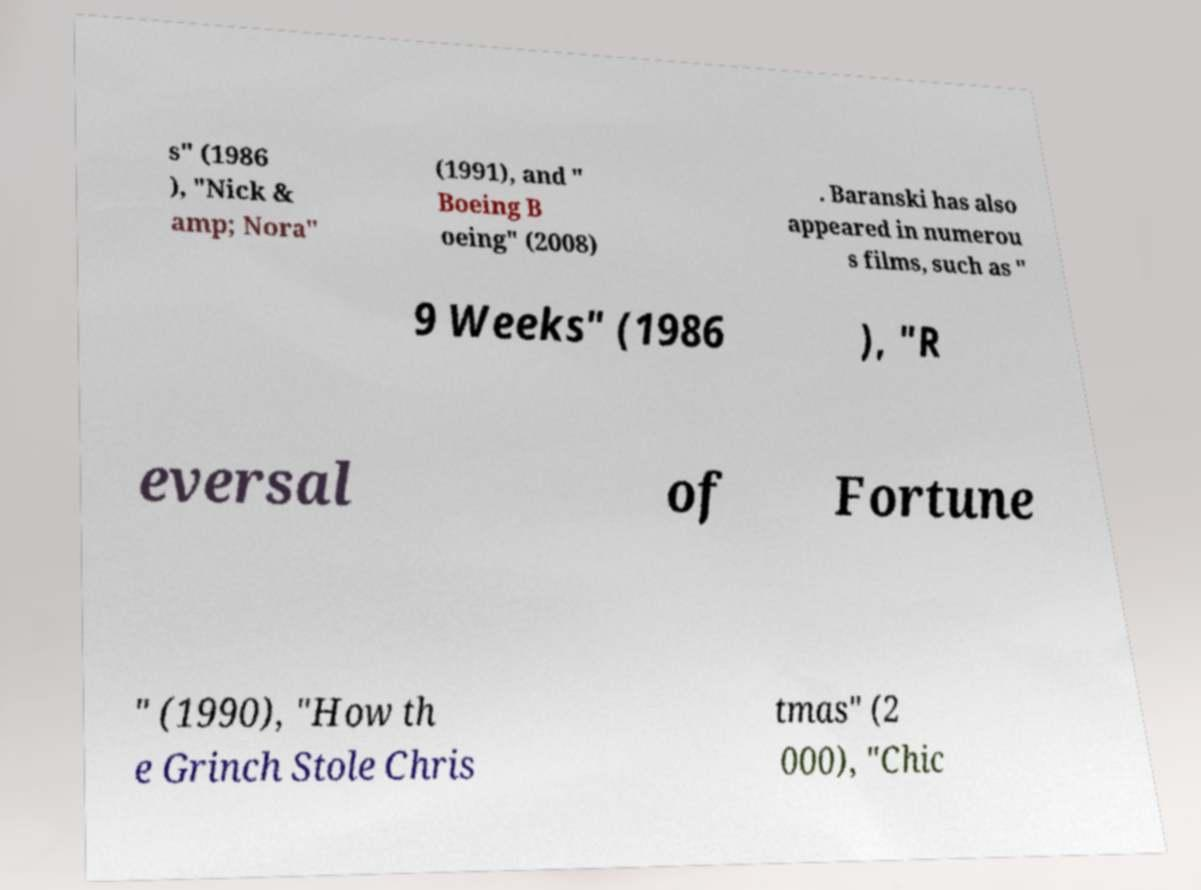Could you extract and type out the text from this image? s" (1986 ), "Nick & amp; Nora" (1991), and " Boeing B oeing" (2008) . Baranski has also appeared in numerou s films, such as " 9 Weeks" (1986 ), "R eversal of Fortune " (1990), "How th e Grinch Stole Chris tmas" (2 000), "Chic 